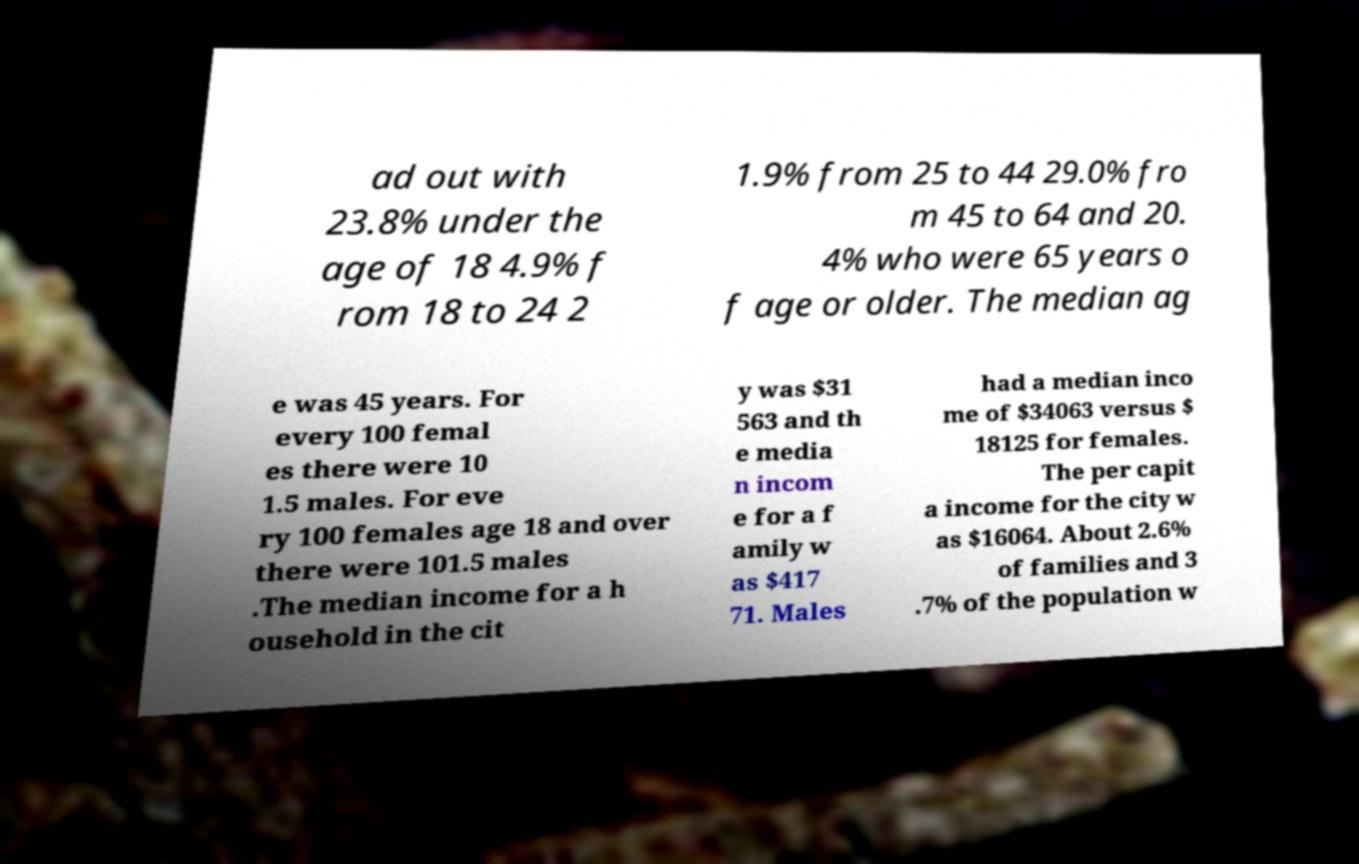What messages or text are displayed in this image? I need them in a readable, typed format. ad out with 23.8% under the age of 18 4.9% f rom 18 to 24 2 1.9% from 25 to 44 29.0% fro m 45 to 64 and 20. 4% who were 65 years o f age or older. The median ag e was 45 years. For every 100 femal es there were 10 1.5 males. For eve ry 100 females age 18 and over there were 101.5 males .The median income for a h ousehold in the cit y was $31 563 and th e media n incom e for a f amily w as $417 71. Males had a median inco me of $34063 versus $ 18125 for females. The per capit a income for the city w as $16064. About 2.6% of families and 3 .7% of the population w 